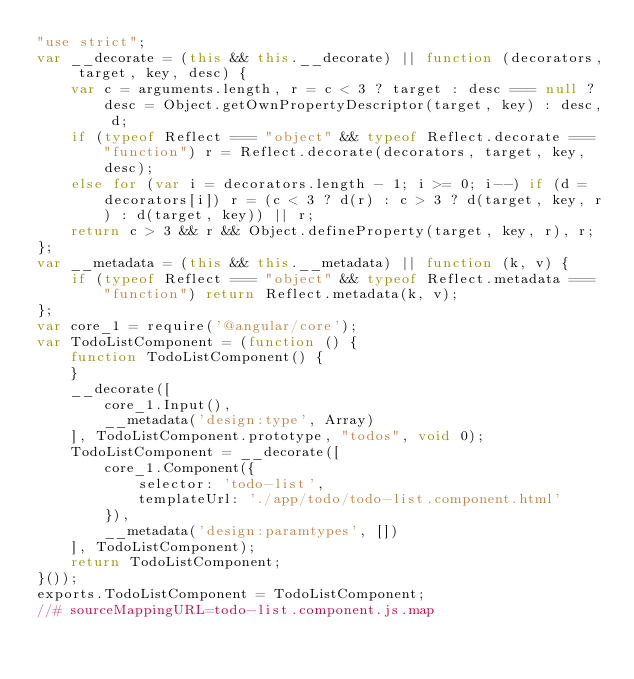Convert code to text. <code><loc_0><loc_0><loc_500><loc_500><_JavaScript_>"use strict";
var __decorate = (this && this.__decorate) || function (decorators, target, key, desc) {
    var c = arguments.length, r = c < 3 ? target : desc === null ? desc = Object.getOwnPropertyDescriptor(target, key) : desc, d;
    if (typeof Reflect === "object" && typeof Reflect.decorate === "function") r = Reflect.decorate(decorators, target, key, desc);
    else for (var i = decorators.length - 1; i >= 0; i--) if (d = decorators[i]) r = (c < 3 ? d(r) : c > 3 ? d(target, key, r) : d(target, key)) || r;
    return c > 3 && r && Object.defineProperty(target, key, r), r;
};
var __metadata = (this && this.__metadata) || function (k, v) {
    if (typeof Reflect === "object" && typeof Reflect.metadata === "function") return Reflect.metadata(k, v);
};
var core_1 = require('@angular/core');
var TodoListComponent = (function () {
    function TodoListComponent() {
    }
    __decorate([
        core_1.Input(), 
        __metadata('design:type', Array)
    ], TodoListComponent.prototype, "todos", void 0);
    TodoListComponent = __decorate([
        core_1.Component({
            selector: 'todo-list',
            templateUrl: './app/todo/todo-list.component.html'
        }), 
        __metadata('design:paramtypes', [])
    ], TodoListComponent);
    return TodoListComponent;
}());
exports.TodoListComponent = TodoListComponent;
//# sourceMappingURL=todo-list.component.js.map</code> 